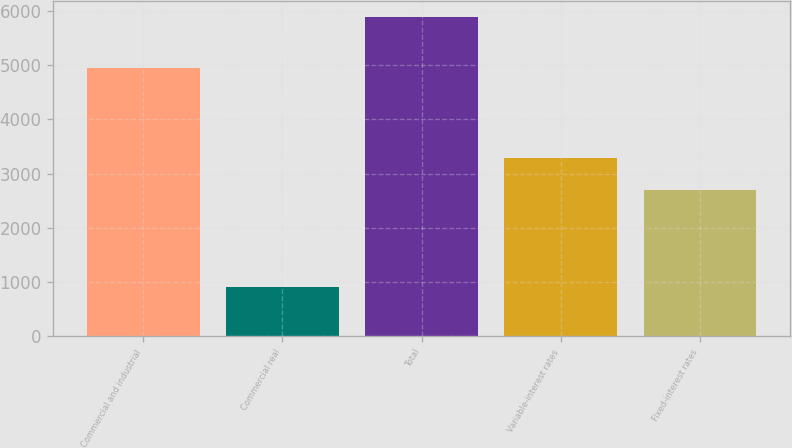Convert chart to OTSL. <chart><loc_0><loc_0><loc_500><loc_500><bar_chart><fcel>Commercial and industrial<fcel>Commercial real<fcel>Total<fcel>Variable-interest rates<fcel>Fixed-interest rates<nl><fcel>4944<fcel>908<fcel>5887<fcel>3286.2<fcel>2701<nl></chart> 